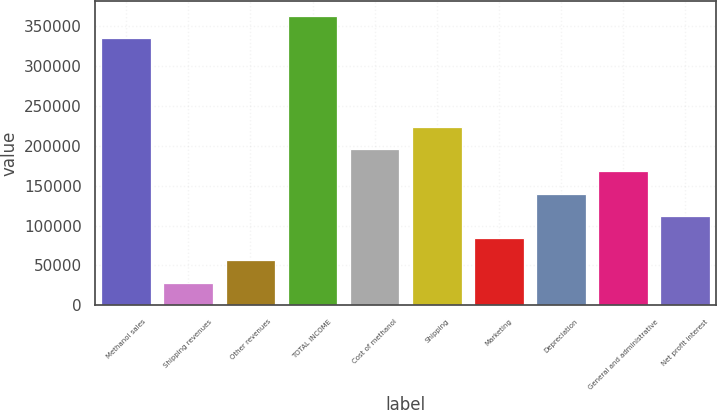Convert chart. <chart><loc_0><loc_0><loc_500><loc_500><bar_chart><fcel>Methanol sales<fcel>Shipping revenues<fcel>Other revenues<fcel>TOTAL INCOME<fcel>Cost of methanol<fcel>Shipping<fcel>Marketing<fcel>Depreciation<fcel>General and administrative<fcel>Net profit interest<nl><fcel>335705<fcel>28443.8<fcel>56376.6<fcel>363637<fcel>196041<fcel>223973<fcel>84309.4<fcel>140175<fcel>168108<fcel>112242<nl></chart> 